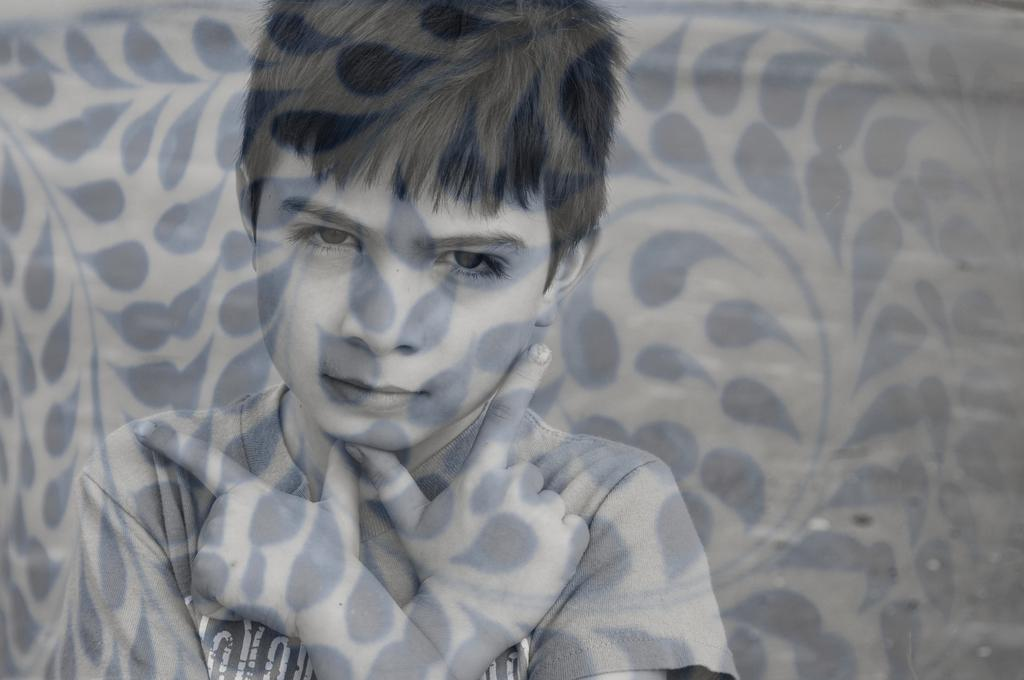What is the main subject of the image? There is a person in the image. What can be observed about the person's appearance in the image? The person has shadow lines on his body. What is visible in the background of the image? There is a wall in the background of the image. Can you describe the design on the wall? The wall has a black colored design. What type of string is being used by the person in the image? There is no string visible in the image. What statement does the person make in the image? The image does not contain any speech or text, so it is not possible to determine any statements made by the person. 